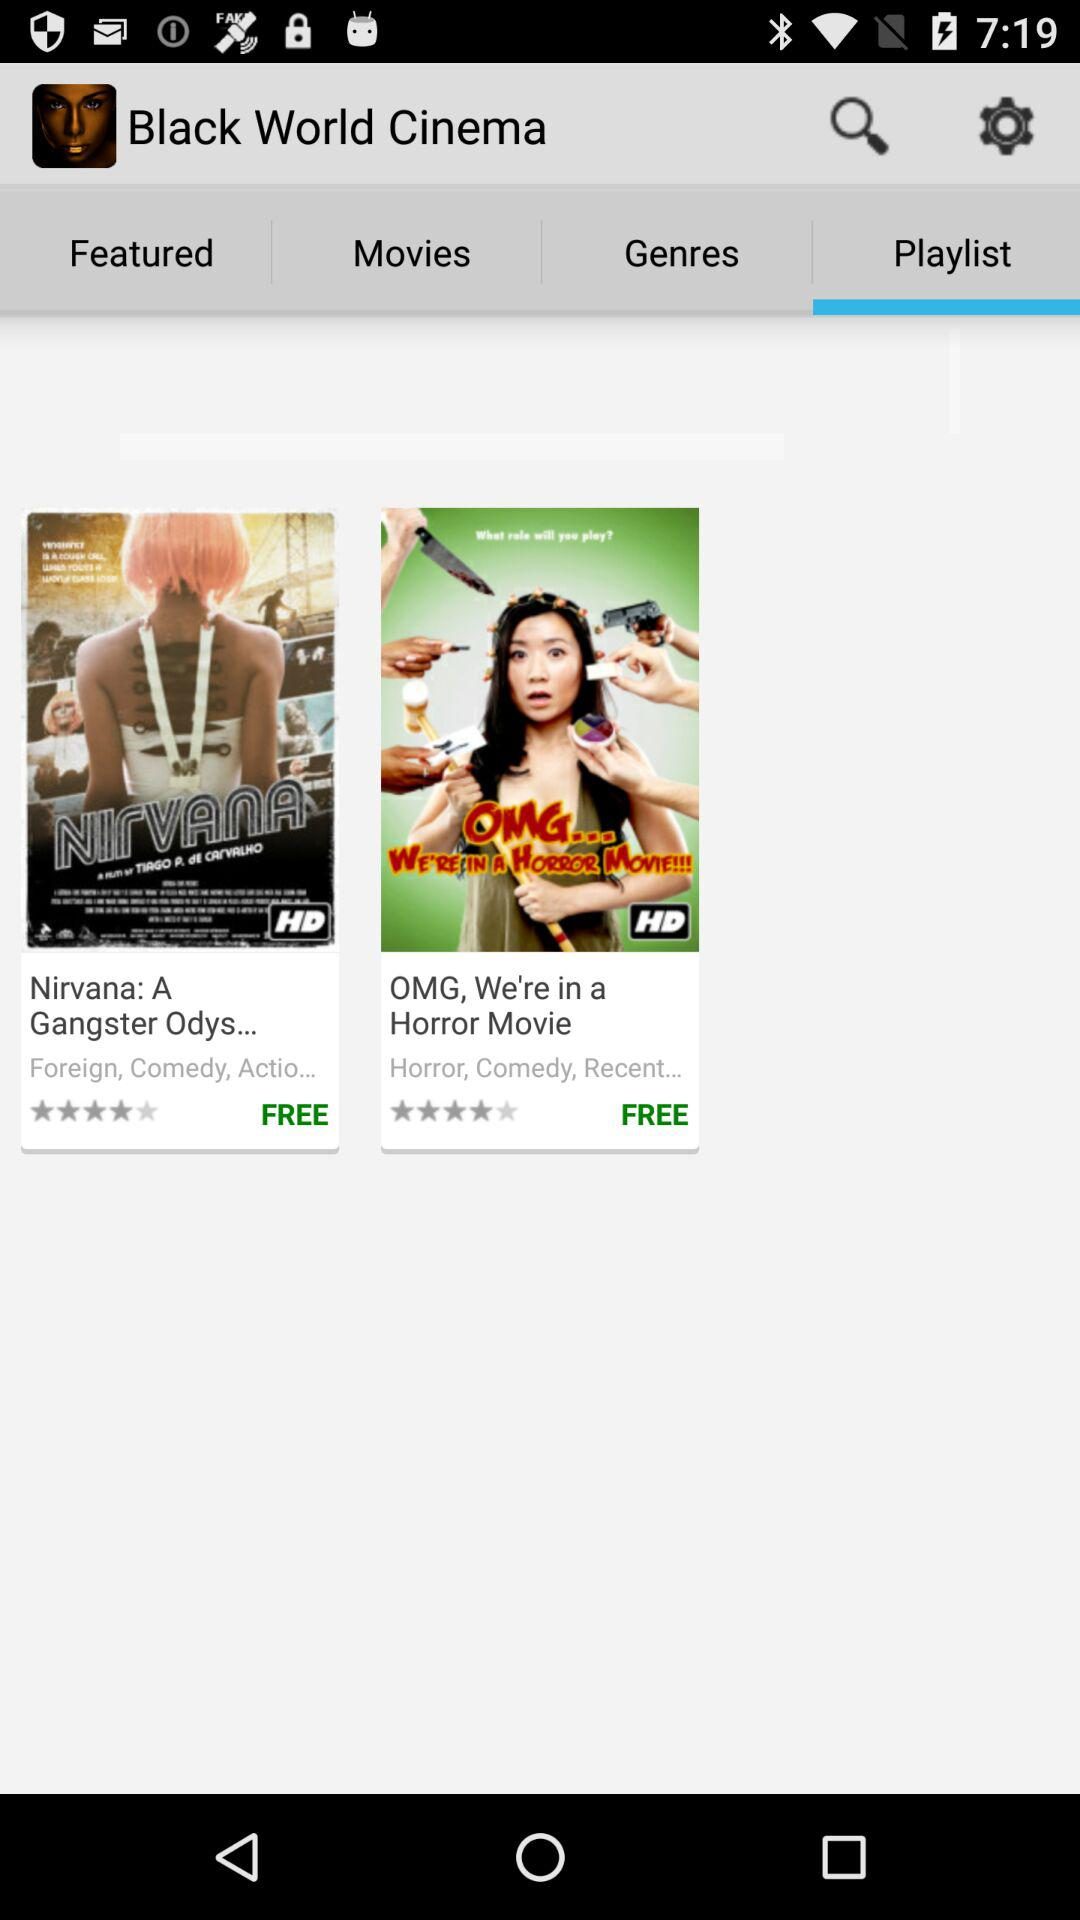What is the star rating of the movie "Nirvana: A Gangster"? "Nirvana: A Gangster" has a four-star rating. 